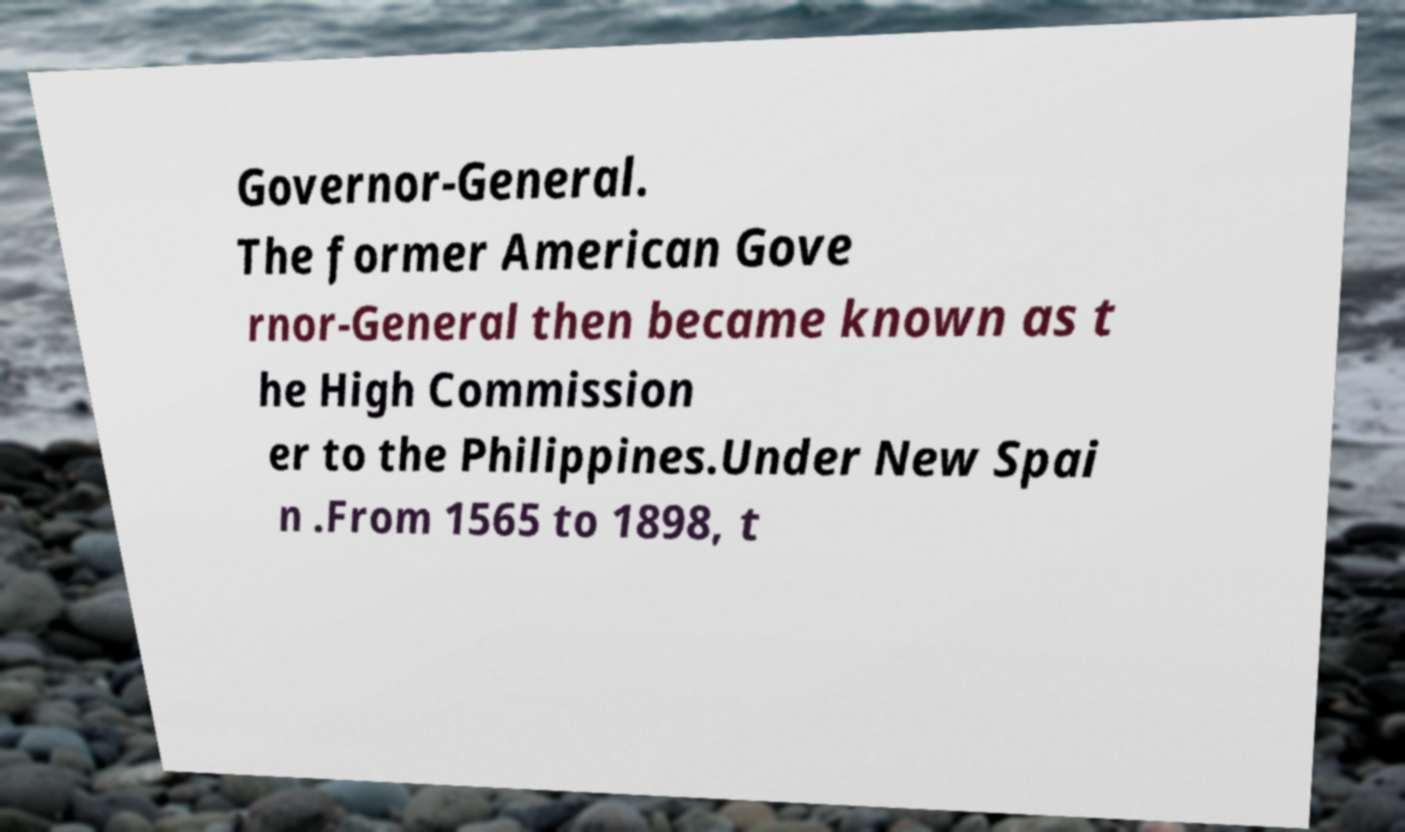Could you assist in decoding the text presented in this image and type it out clearly? Governor-General. The former American Gove rnor-General then became known as t he High Commission er to the Philippines.Under New Spai n .From 1565 to 1898, t 